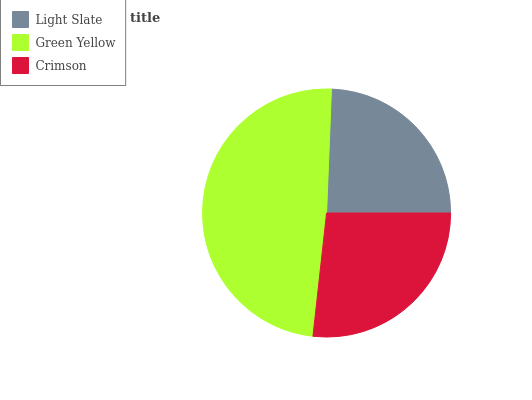Is Light Slate the minimum?
Answer yes or no. Yes. Is Green Yellow the maximum?
Answer yes or no. Yes. Is Crimson the minimum?
Answer yes or no. No. Is Crimson the maximum?
Answer yes or no. No. Is Green Yellow greater than Crimson?
Answer yes or no. Yes. Is Crimson less than Green Yellow?
Answer yes or no. Yes. Is Crimson greater than Green Yellow?
Answer yes or no. No. Is Green Yellow less than Crimson?
Answer yes or no. No. Is Crimson the high median?
Answer yes or no. Yes. Is Crimson the low median?
Answer yes or no. Yes. Is Light Slate the high median?
Answer yes or no. No. Is Green Yellow the low median?
Answer yes or no. No. 